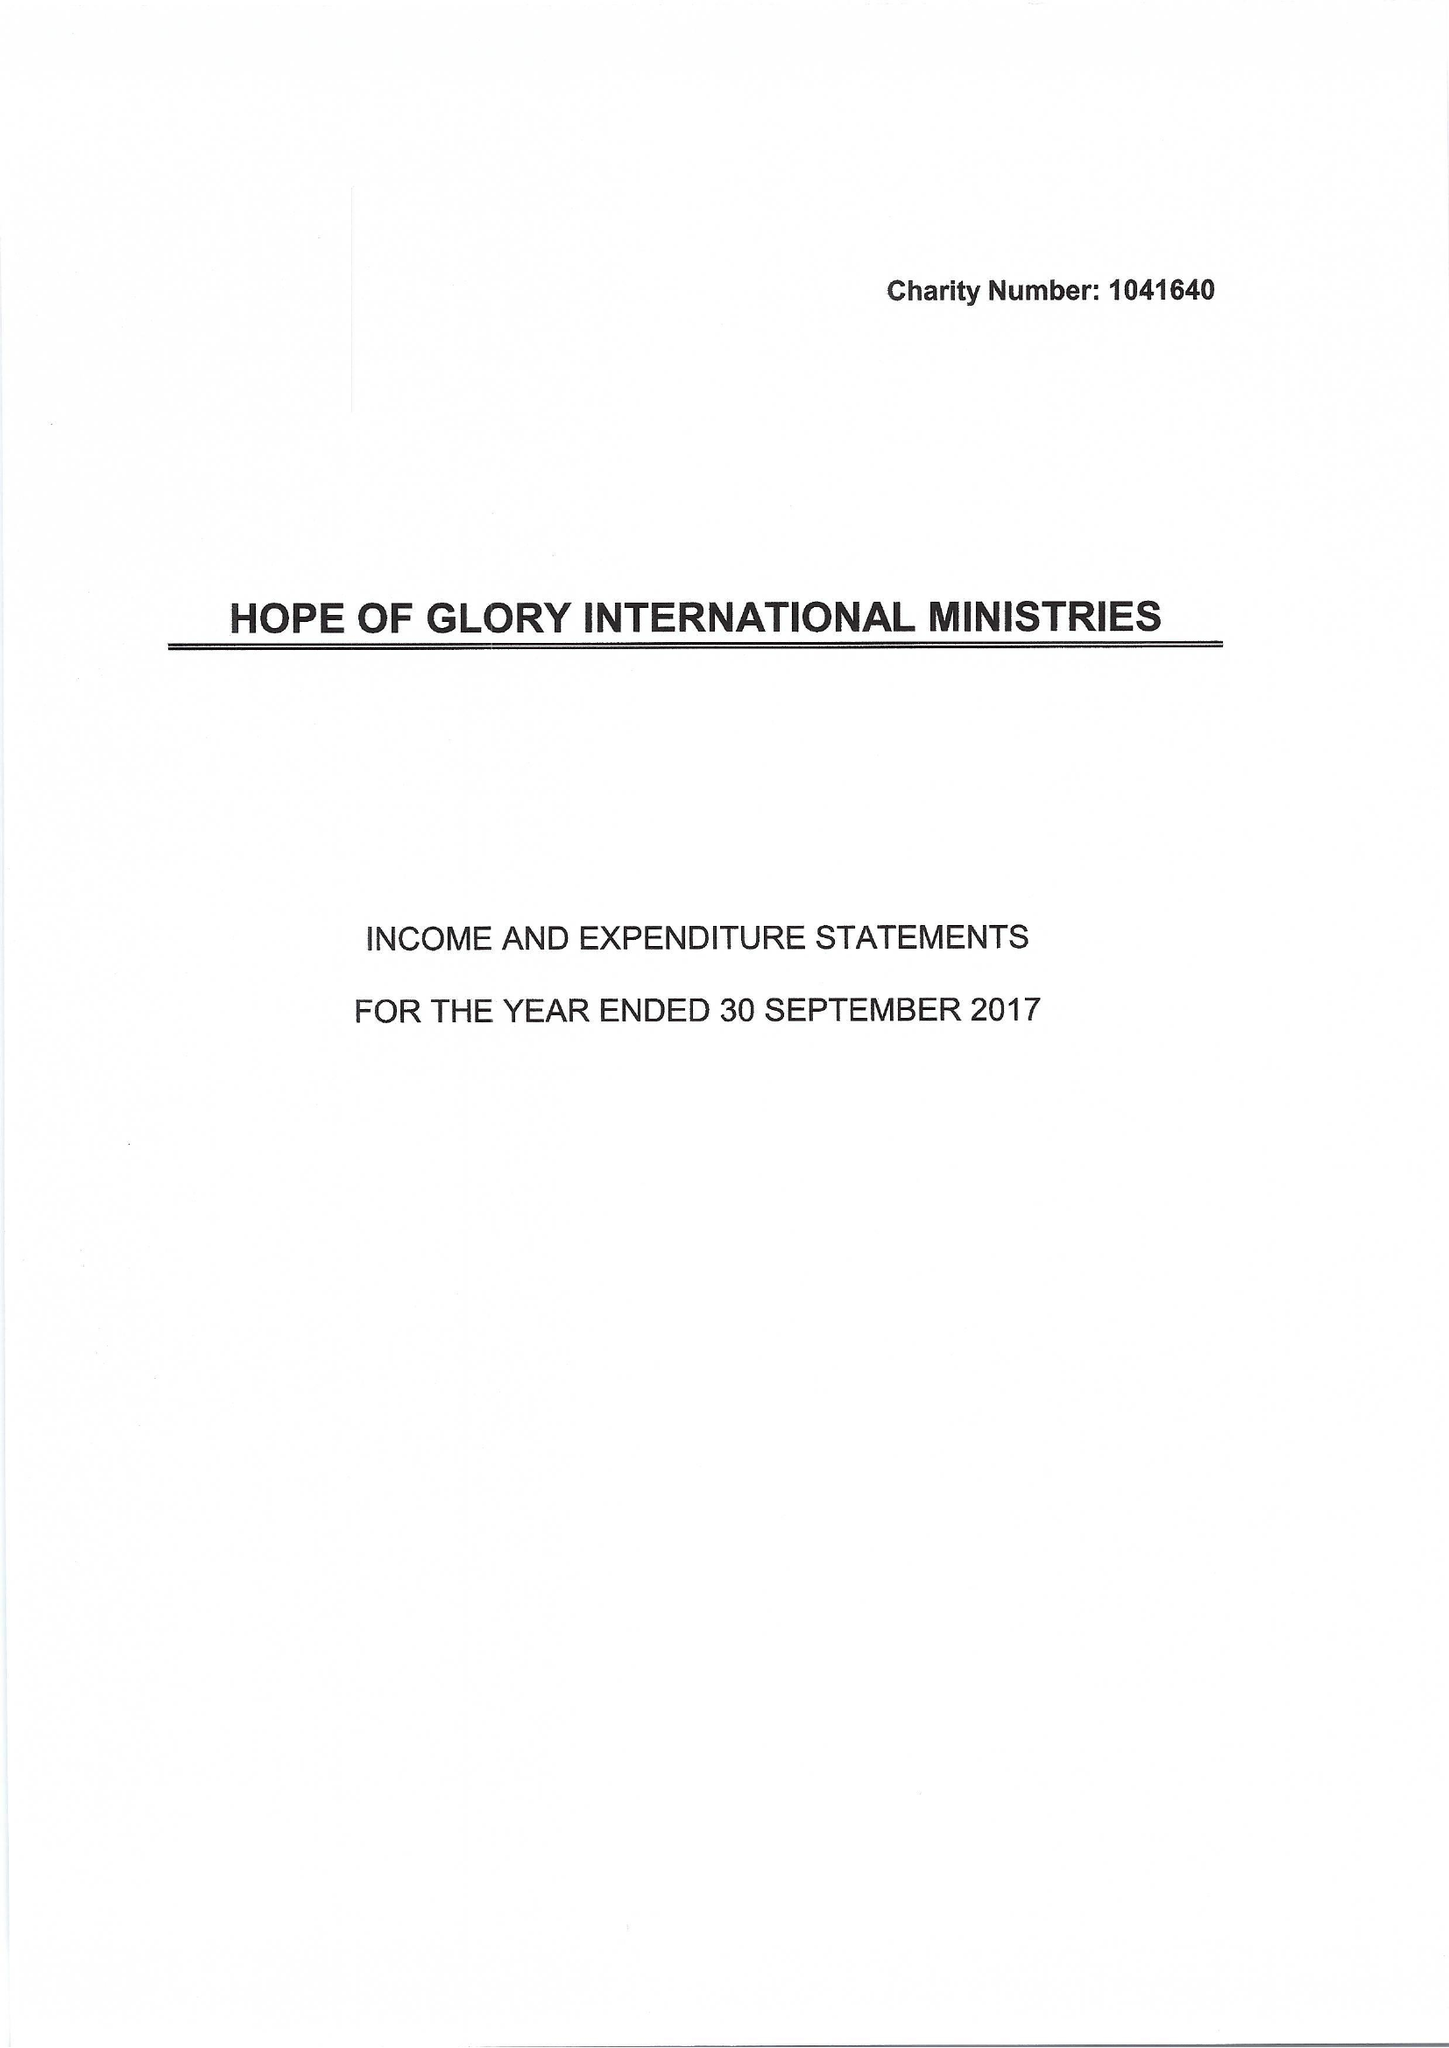What is the value for the charity_name?
Answer the question using a single word or phrase. Hope Of Glory International Ministries 